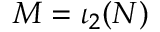Convert formula to latex. <formula><loc_0><loc_0><loc_500><loc_500>M = \iota _ { 2 } ( N )</formula> 